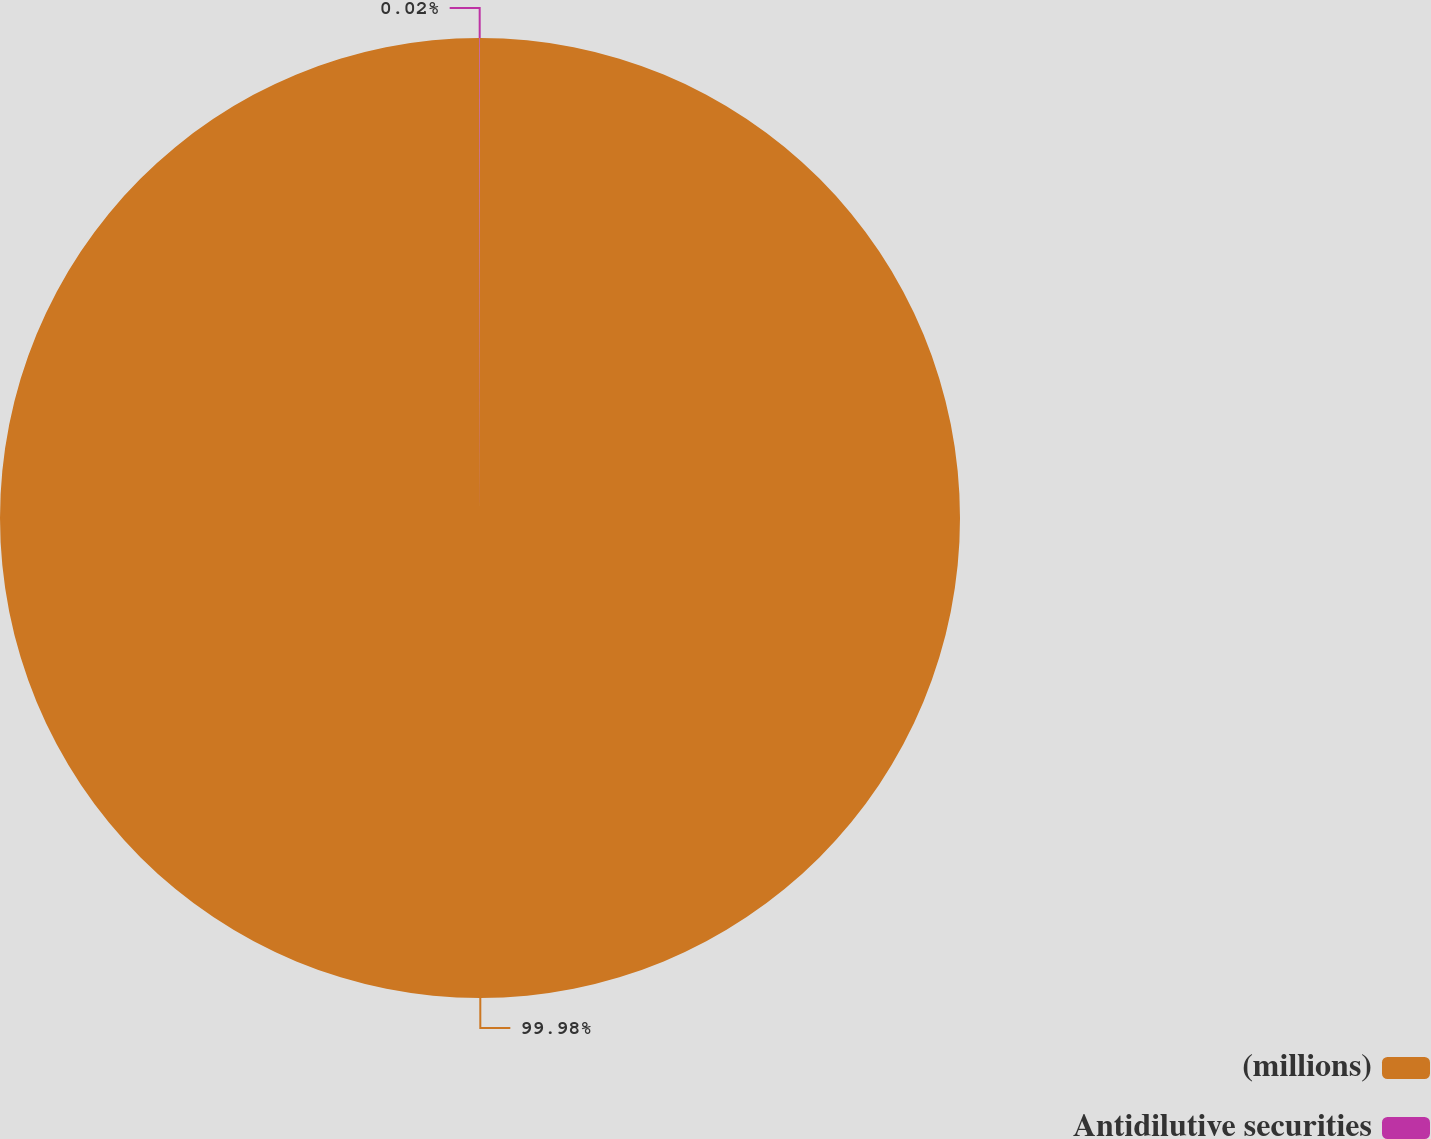Convert chart to OTSL. <chart><loc_0><loc_0><loc_500><loc_500><pie_chart><fcel>(millions)<fcel>Antidilutive securities<nl><fcel>99.98%<fcel>0.02%<nl></chart> 